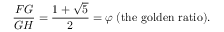<formula> <loc_0><loc_0><loc_500><loc_500>{ \frac { F G } { G H } } = { \frac { 1 + { \sqrt { 5 } } } { 2 } } = \varphi \, ( { t h e g o l d e n r a t i o } ) .</formula> 